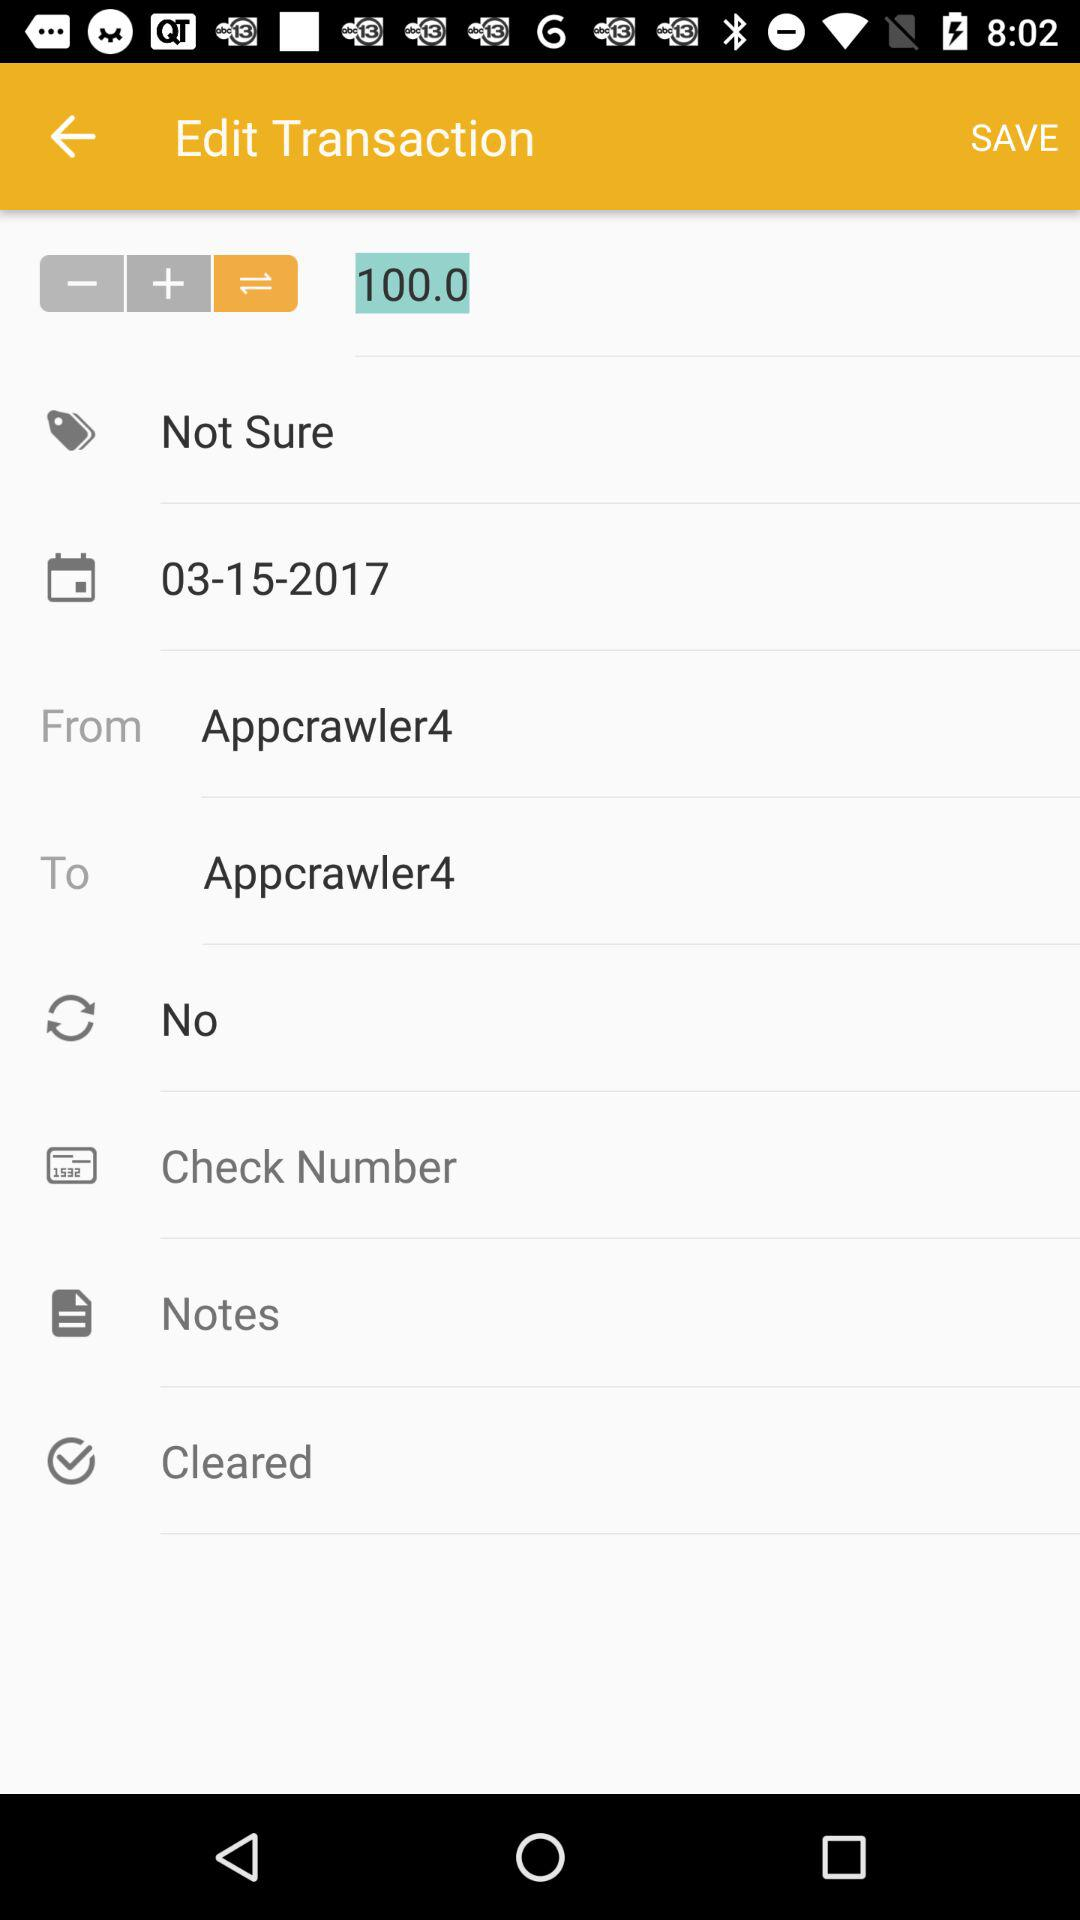How much is the amount of the transaction?
Answer the question using a single word or phrase. 100.0 